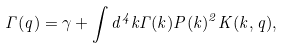<formula> <loc_0><loc_0><loc_500><loc_500>\Gamma ( q ) = \gamma + \int d ^ { 4 } k \Gamma ( k ) P ( k ) ^ { 2 } K ( k , q ) ,</formula> 